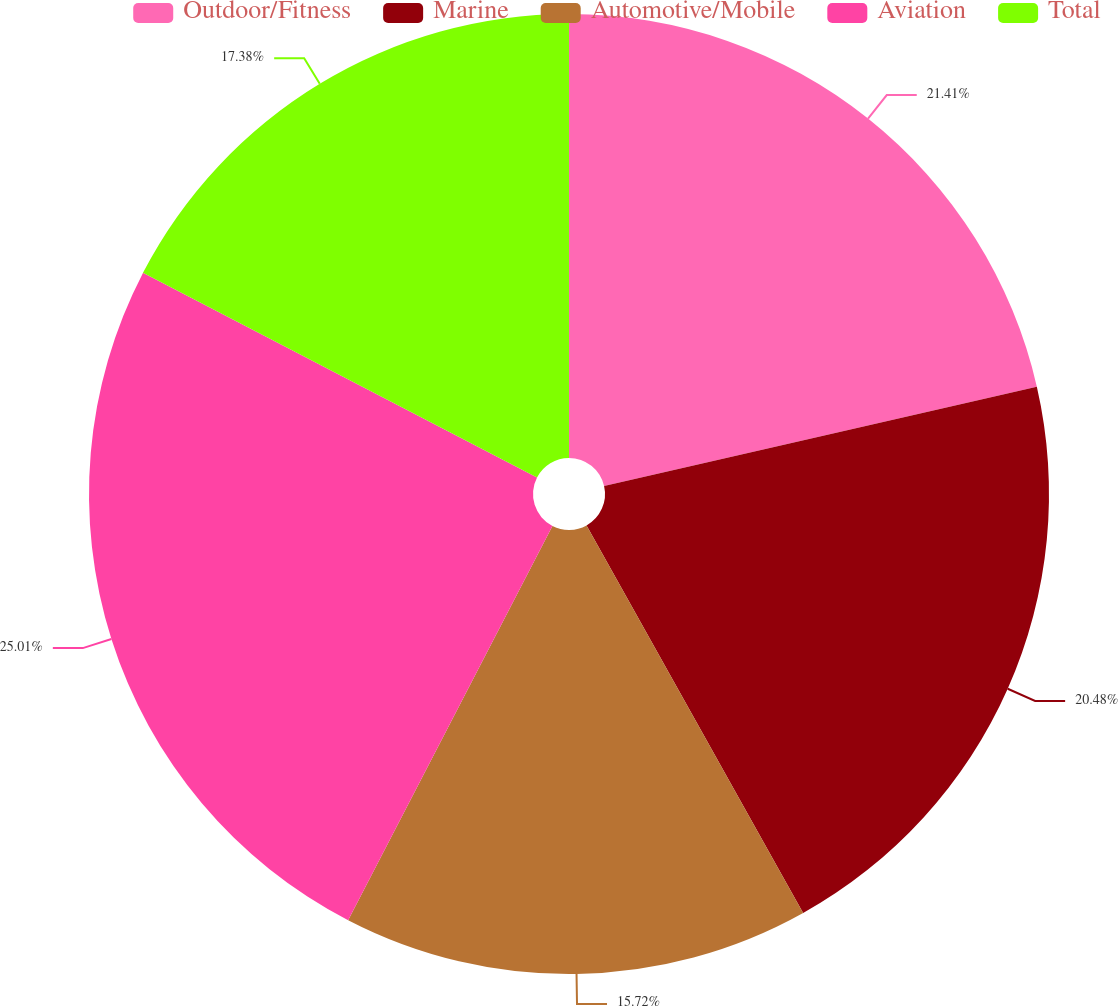Convert chart to OTSL. <chart><loc_0><loc_0><loc_500><loc_500><pie_chart><fcel>Outdoor/Fitness<fcel>Marine<fcel>Automotive/Mobile<fcel>Aviation<fcel>Total<nl><fcel>21.41%<fcel>20.48%<fcel>15.72%<fcel>25.01%<fcel>17.38%<nl></chart> 